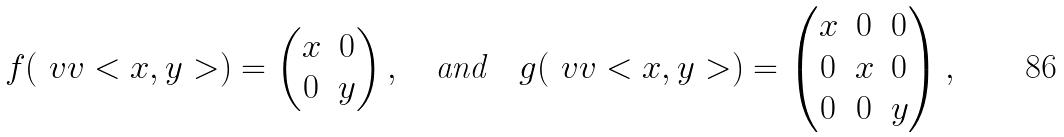<formula> <loc_0><loc_0><loc_500><loc_500>f ( \ v v < x , y > ) = \begin{pmatrix} x & 0 \\ 0 & y \end{pmatrix} , \quad \text {and} \quad g ( \ v v < x , y > ) = \begin{pmatrix} x & 0 & 0 \\ 0 & x & 0 \\ 0 & 0 & y \end{pmatrix} ,</formula> 